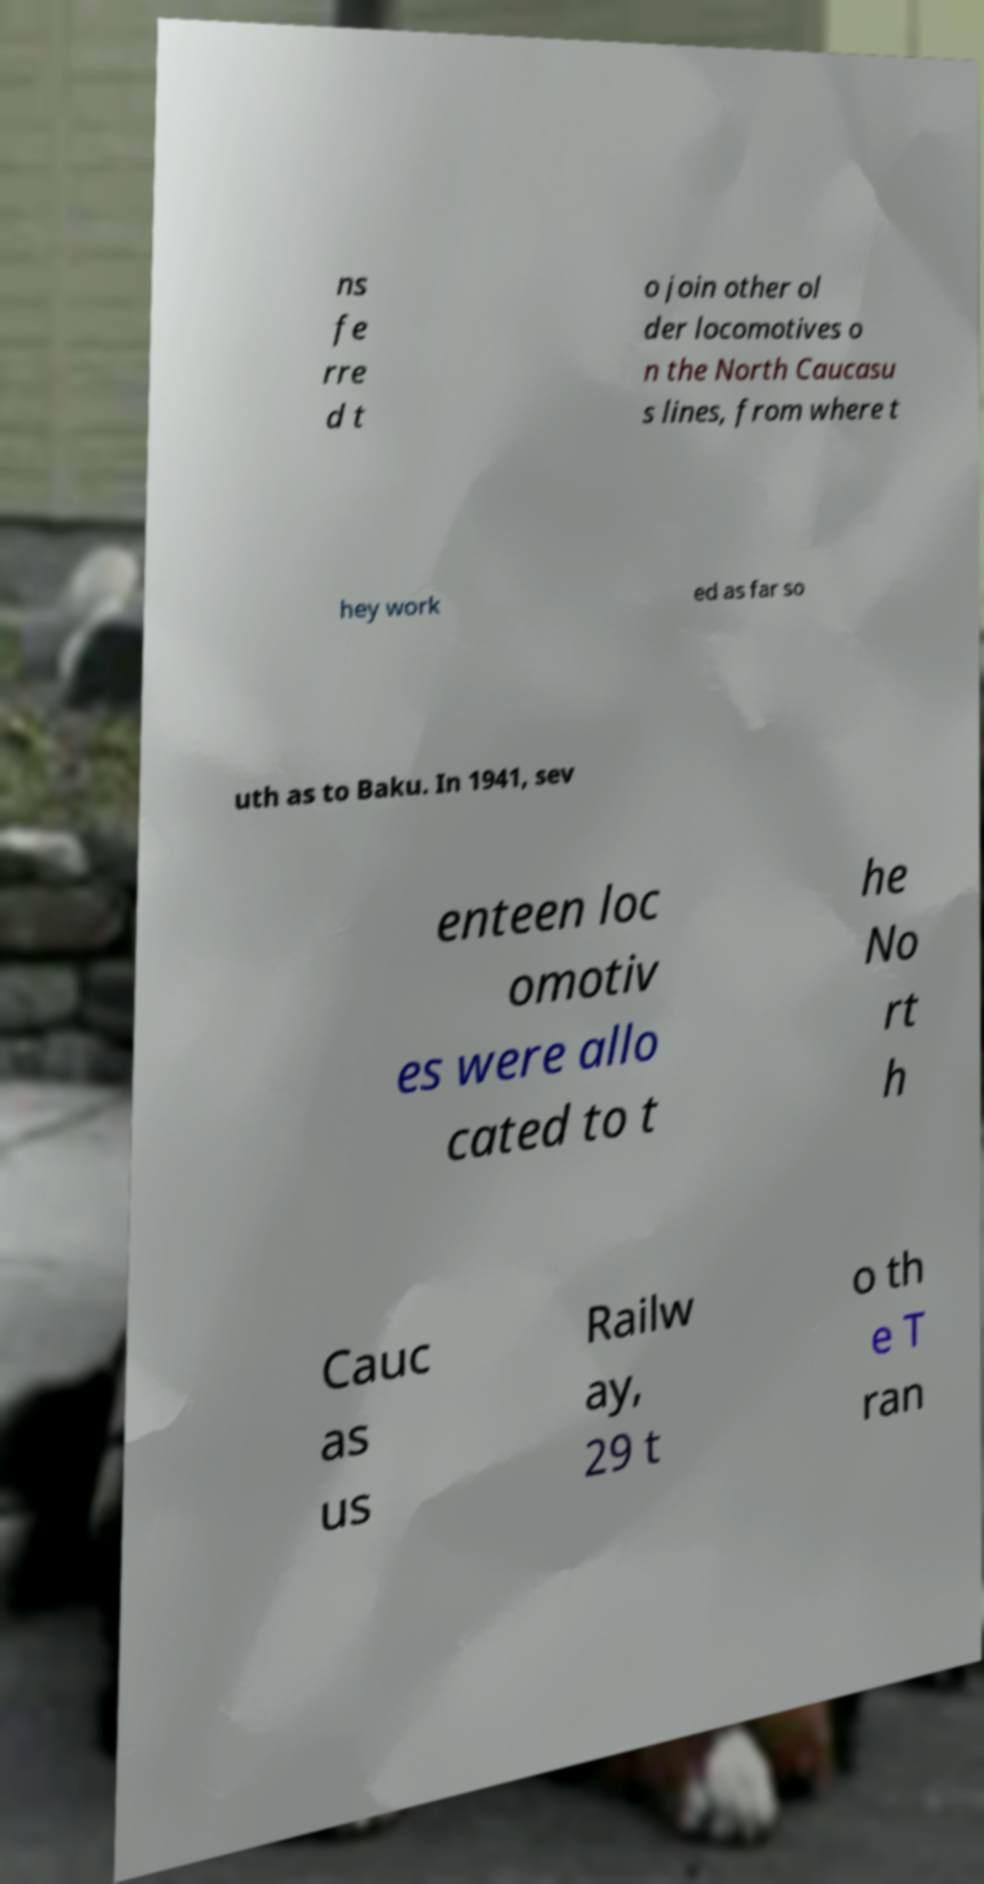Please read and relay the text visible in this image. What does it say? ns fe rre d t o join other ol der locomotives o n the North Caucasu s lines, from where t hey work ed as far so uth as to Baku. In 1941, sev enteen loc omotiv es were allo cated to t he No rt h Cauc as us Railw ay, 29 t o th e T ran 